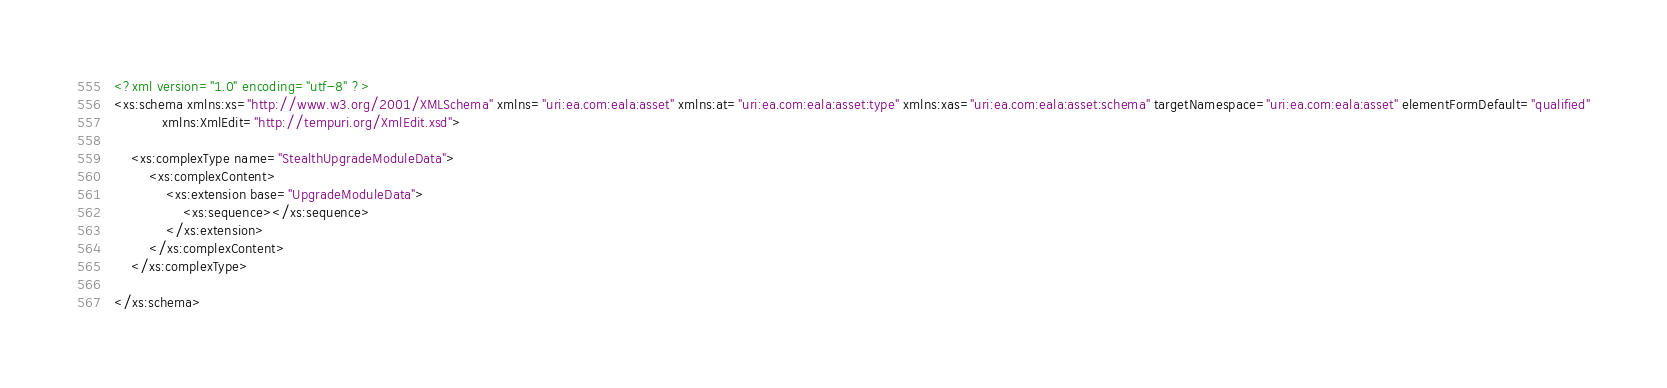Convert code to text. <code><loc_0><loc_0><loc_500><loc_500><_XML_><?xml version="1.0" encoding="utf-8" ?>
<xs:schema xmlns:xs="http://www.w3.org/2001/XMLSchema" xmlns="uri:ea.com:eala:asset" xmlns:at="uri:ea.com:eala:asset:type" xmlns:xas="uri:ea.com:eala:asset:schema" targetNamespace="uri:ea.com:eala:asset" elementFormDefault="qualified"
           xmlns:XmlEdit="http://tempuri.org/XmlEdit.xsd">

    <xs:complexType name="StealthUpgradeModuleData">
        <xs:complexContent>
            <xs:extension base="UpgradeModuleData">
                <xs:sequence></xs:sequence>
            </xs:extension>
        </xs:complexContent>
    </xs:complexType>

</xs:schema>
</code> 